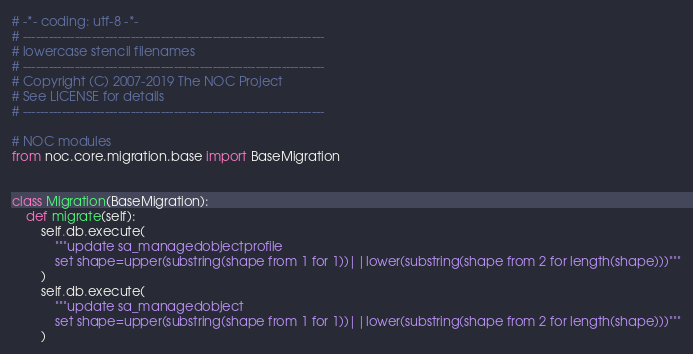<code> <loc_0><loc_0><loc_500><loc_500><_Python_># -*- coding: utf-8 -*-
# ----------------------------------------------------------------------
# lowercase stencil filenames
# ----------------------------------------------------------------------
# Copyright (C) 2007-2019 The NOC Project
# See LICENSE for details
# ----------------------------------------------------------------------

# NOC modules
from noc.core.migration.base import BaseMigration


class Migration(BaseMigration):
    def migrate(self):
        self.db.execute(
            """update sa_managedobjectprofile
            set shape=upper(substring(shape from 1 for 1))||lower(substring(shape from 2 for length(shape)))"""
        )
        self.db.execute(
            """update sa_managedobject
            set shape=upper(substring(shape from 1 for 1))||lower(substring(shape from 2 for length(shape)))"""
        )
</code> 